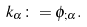<formula> <loc_0><loc_0><loc_500><loc_500>k _ { \alpha } \colon = \phi _ { ; \alpha } .</formula> 